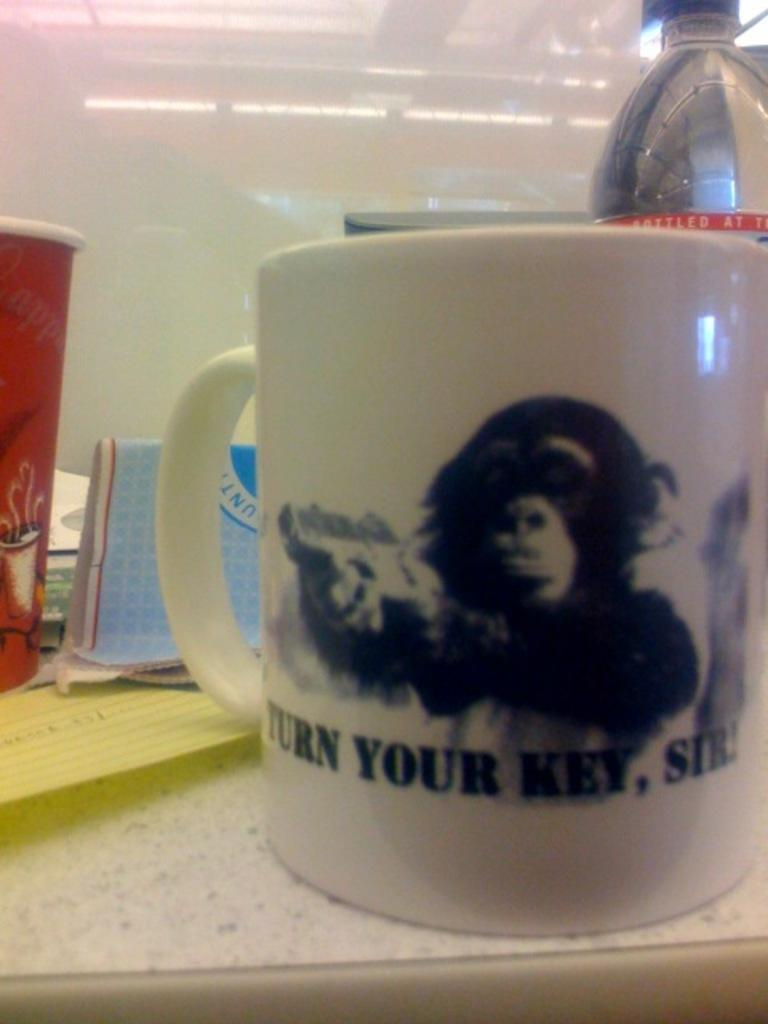<image>
Share a concise interpretation of the image provided. white coffee mug with chimp holding a gun and words beneath "turn your key, sir!" 